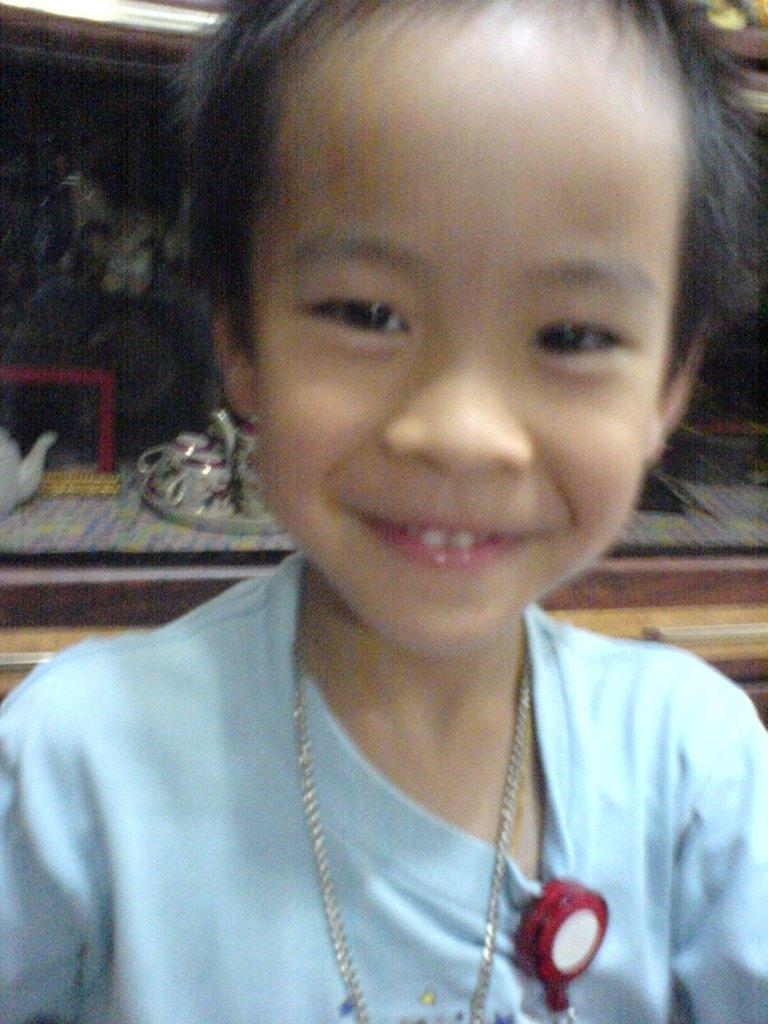What is the person in the image wearing? The person in the image is wearing a blue dress. What can be seen in the background of the image? In the background of the image, there is a cup, a flower pot, and other objects. What is the color of the background in the image? The background of the image is black. How many friends does the person in the image have? The image does not provide information about the person's friends, so it cannot be determined from the image. 